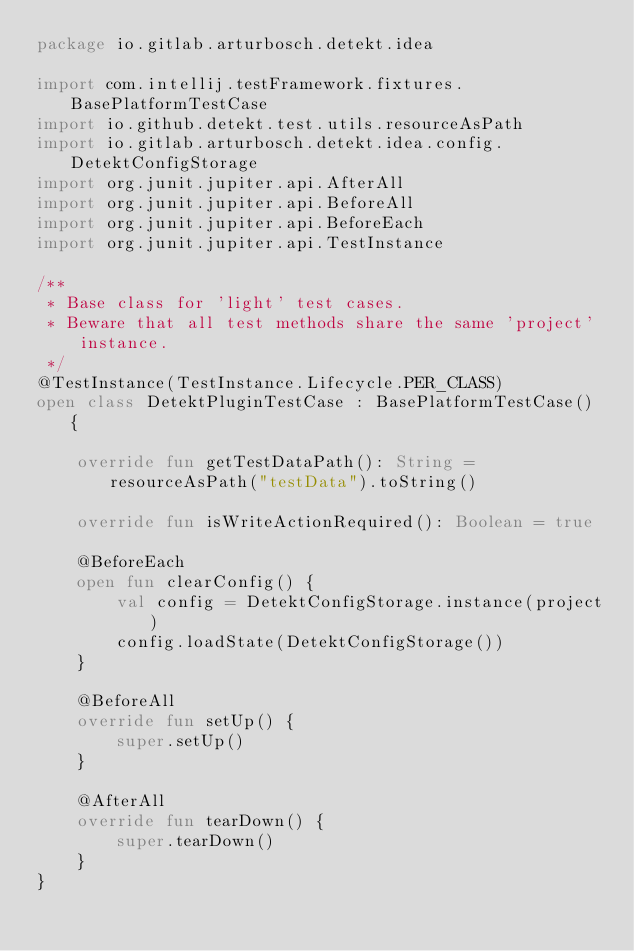Convert code to text. <code><loc_0><loc_0><loc_500><loc_500><_Kotlin_>package io.gitlab.arturbosch.detekt.idea

import com.intellij.testFramework.fixtures.BasePlatformTestCase
import io.github.detekt.test.utils.resourceAsPath
import io.gitlab.arturbosch.detekt.idea.config.DetektConfigStorage
import org.junit.jupiter.api.AfterAll
import org.junit.jupiter.api.BeforeAll
import org.junit.jupiter.api.BeforeEach
import org.junit.jupiter.api.TestInstance

/**
 * Base class for 'light' test cases.
 * Beware that all test methods share the same 'project' instance.
 */
@TestInstance(TestInstance.Lifecycle.PER_CLASS)
open class DetektPluginTestCase : BasePlatformTestCase() {

    override fun getTestDataPath(): String = resourceAsPath("testData").toString()

    override fun isWriteActionRequired(): Boolean = true

    @BeforeEach
    open fun clearConfig() {
        val config = DetektConfigStorage.instance(project)
        config.loadState(DetektConfigStorage())
    }

    @BeforeAll
    override fun setUp() {
        super.setUp()
    }

    @AfterAll
    override fun tearDown() {
        super.tearDown()
    }
}
</code> 